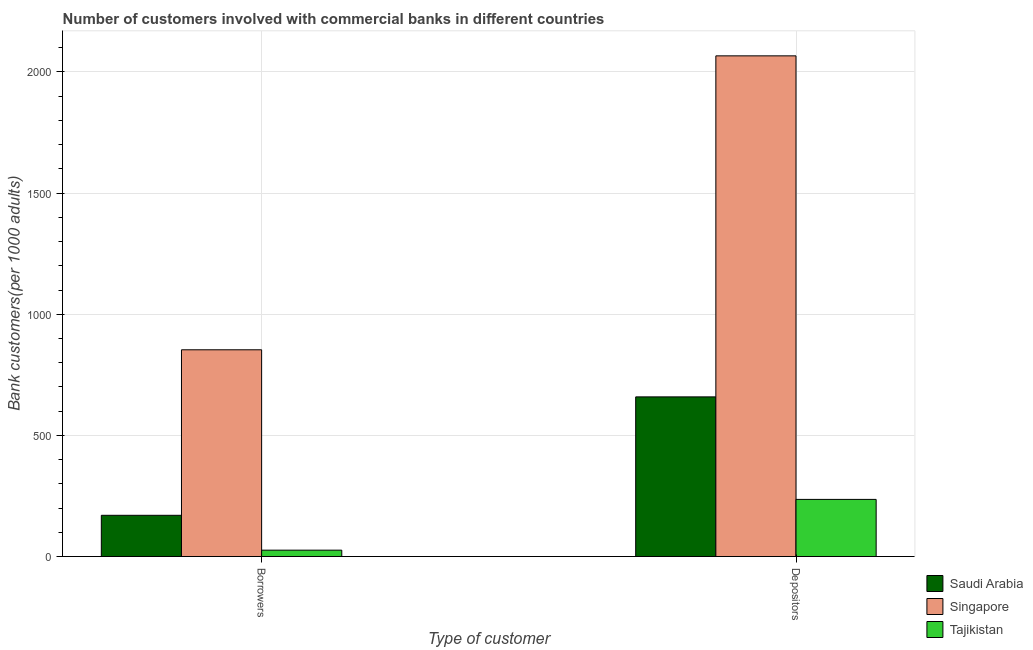How many different coloured bars are there?
Your answer should be compact. 3. How many groups of bars are there?
Your response must be concise. 2. What is the label of the 2nd group of bars from the left?
Provide a succinct answer. Depositors. What is the number of borrowers in Singapore?
Provide a succinct answer. 853.36. Across all countries, what is the maximum number of depositors?
Your response must be concise. 2066.57. Across all countries, what is the minimum number of borrowers?
Provide a succinct answer. 26.29. In which country was the number of depositors maximum?
Offer a terse response. Singapore. In which country was the number of borrowers minimum?
Offer a very short reply. Tajikistan. What is the total number of borrowers in the graph?
Offer a very short reply. 1049.83. What is the difference between the number of borrowers in Tajikistan and that in Singapore?
Make the answer very short. -827.07. What is the difference between the number of depositors in Saudi Arabia and the number of borrowers in Tajikistan?
Give a very brief answer. 632.72. What is the average number of borrowers per country?
Keep it short and to the point. 349.94. What is the difference between the number of borrowers and number of depositors in Singapore?
Your answer should be very brief. -1213.21. What is the ratio of the number of borrowers in Singapore to that in Saudi Arabia?
Provide a short and direct response. 5.01. Is the number of borrowers in Tajikistan less than that in Saudi Arabia?
Offer a terse response. Yes. What does the 2nd bar from the left in Depositors represents?
Ensure brevity in your answer.  Singapore. What does the 2nd bar from the right in Depositors represents?
Offer a terse response. Singapore. How many countries are there in the graph?
Provide a succinct answer. 3. What is the difference between two consecutive major ticks on the Y-axis?
Your answer should be compact. 500. Are the values on the major ticks of Y-axis written in scientific E-notation?
Your answer should be compact. No. Does the graph contain grids?
Your response must be concise. Yes. How many legend labels are there?
Give a very brief answer. 3. What is the title of the graph?
Provide a short and direct response. Number of customers involved with commercial banks in different countries. What is the label or title of the X-axis?
Give a very brief answer. Type of customer. What is the label or title of the Y-axis?
Your response must be concise. Bank customers(per 1000 adults). What is the Bank customers(per 1000 adults) of Saudi Arabia in Borrowers?
Your response must be concise. 170.18. What is the Bank customers(per 1000 adults) in Singapore in Borrowers?
Offer a terse response. 853.36. What is the Bank customers(per 1000 adults) in Tajikistan in Borrowers?
Your answer should be compact. 26.29. What is the Bank customers(per 1000 adults) of Saudi Arabia in Depositors?
Give a very brief answer. 659. What is the Bank customers(per 1000 adults) of Singapore in Depositors?
Offer a very short reply. 2066.57. What is the Bank customers(per 1000 adults) in Tajikistan in Depositors?
Your answer should be compact. 235.83. Across all Type of customer, what is the maximum Bank customers(per 1000 adults) in Saudi Arabia?
Give a very brief answer. 659. Across all Type of customer, what is the maximum Bank customers(per 1000 adults) in Singapore?
Ensure brevity in your answer.  2066.57. Across all Type of customer, what is the maximum Bank customers(per 1000 adults) in Tajikistan?
Your answer should be compact. 235.83. Across all Type of customer, what is the minimum Bank customers(per 1000 adults) in Saudi Arabia?
Your response must be concise. 170.18. Across all Type of customer, what is the minimum Bank customers(per 1000 adults) in Singapore?
Give a very brief answer. 853.36. Across all Type of customer, what is the minimum Bank customers(per 1000 adults) of Tajikistan?
Offer a terse response. 26.29. What is the total Bank customers(per 1000 adults) of Saudi Arabia in the graph?
Provide a succinct answer. 829.19. What is the total Bank customers(per 1000 adults) of Singapore in the graph?
Offer a terse response. 2919.93. What is the total Bank customers(per 1000 adults) of Tajikistan in the graph?
Offer a terse response. 262.11. What is the difference between the Bank customers(per 1000 adults) of Saudi Arabia in Borrowers and that in Depositors?
Provide a short and direct response. -488.82. What is the difference between the Bank customers(per 1000 adults) of Singapore in Borrowers and that in Depositors?
Keep it short and to the point. -1213.21. What is the difference between the Bank customers(per 1000 adults) in Tajikistan in Borrowers and that in Depositors?
Your answer should be very brief. -209.54. What is the difference between the Bank customers(per 1000 adults) in Saudi Arabia in Borrowers and the Bank customers(per 1000 adults) in Singapore in Depositors?
Give a very brief answer. -1896.39. What is the difference between the Bank customers(per 1000 adults) of Saudi Arabia in Borrowers and the Bank customers(per 1000 adults) of Tajikistan in Depositors?
Give a very brief answer. -65.64. What is the difference between the Bank customers(per 1000 adults) in Singapore in Borrowers and the Bank customers(per 1000 adults) in Tajikistan in Depositors?
Provide a succinct answer. 617.53. What is the average Bank customers(per 1000 adults) of Saudi Arabia per Type of customer?
Give a very brief answer. 414.59. What is the average Bank customers(per 1000 adults) in Singapore per Type of customer?
Make the answer very short. 1459.97. What is the average Bank customers(per 1000 adults) of Tajikistan per Type of customer?
Make the answer very short. 131.06. What is the difference between the Bank customers(per 1000 adults) of Saudi Arabia and Bank customers(per 1000 adults) of Singapore in Borrowers?
Provide a succinct answer. -683.18. What is the difference between the Bank customers(per 1000 adults) of Saudi Arabia and Bank customers(per 1000 adults) of Tajikistan in Borrowers?
Give a very brief answer. 143.9. What is the difference between the Bank customers(per 1000 adults) of Singapore and Bank customers(per 1000 adults) of Tajikistan in Borrowers?
Your response must be concise. 827.07. What is the difference between the Bank customers(per 1000 adults) in Saudi Arabia and Bank customers(per 1000 adults) in Singapore in Depositors?
Provide a short and direct response. -1407.57. What is the difference between the Bank customers(per 1000 adults) in Saudi Arabia and Bank customers(per 1000 adults) in Tajikistan in Depositors?
Your answer should be compact. 423.18. What is the difference between the Bank customers(per 1000 adults) in Singapore and Bank customers(per 1000 adults) in Tajikistan in Depositors?
Your response must be concise. 1830.75. What is the ratio of the Bank customers(per 1000 adults) in Saudi Arabia in Borrowers to that in Depositors?
Make the answer very short. 0.26. What is the ratio of the Bank customers(per 1000 adults) of Singapore in Borrowers to that in Depositors?
Offer a terse response. 0.41. What is the ratio of the Bank customers(per 1000 adults) of Tajikistan in Borrowers to that in Depositors?
Offer a terse response. 0.11. What is the difference between the highest and the second highest Bank customers(per 1000 adults) of Saudi Arabia?
Make the answer very short. 488.82. What is the difference between the highest and the second highest Bank customers(per 1000 adults) of Singapore?
Ensure brevity in your answer.  1213.21. What is the difference between the highest and the second highest Bank customers(per 1000 adults) of Tajikistan?
Your answer should be compact. 209.54. What is the difference between the highest and the lowest Bank customers(per 1000 adults) in Saudi Arabia?
Your response must be concise. 488.82. What is the difference between the highest and the lowest Bank customers(per 1000 adults) of Singapore?
Your response must be concise. 1213.21. What is the difference between the highest and the lowest Bank customers(per 1000 adults) of Tajikistan?
Your answer should be compact. 209.54. 